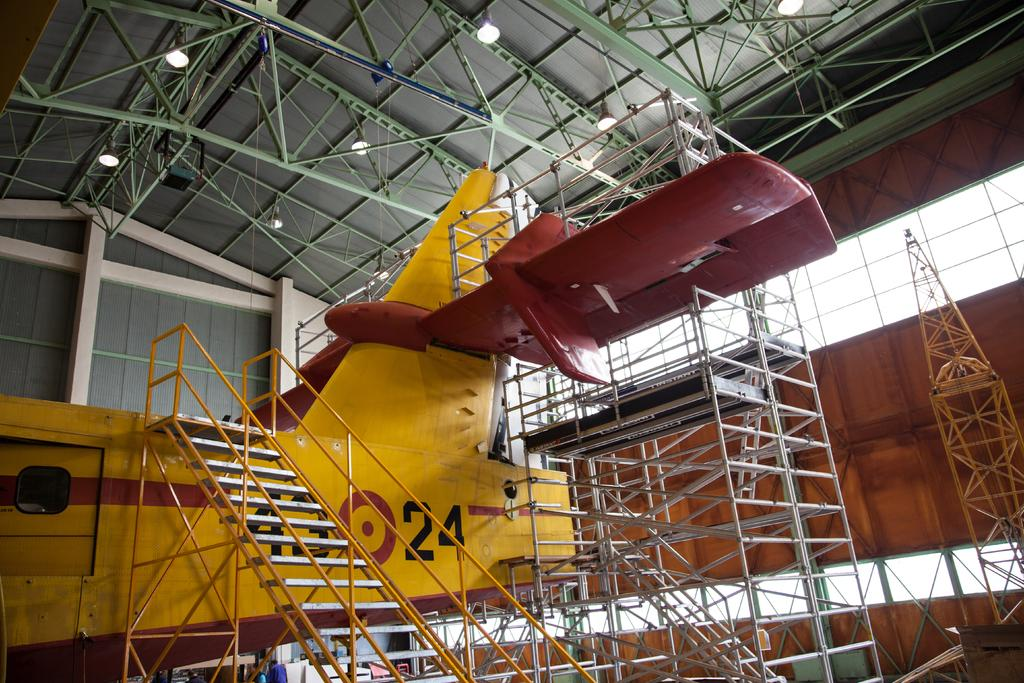<image>
Present a compact description of the photo's key features. A yellow and maroon with the number 24 on the side. 